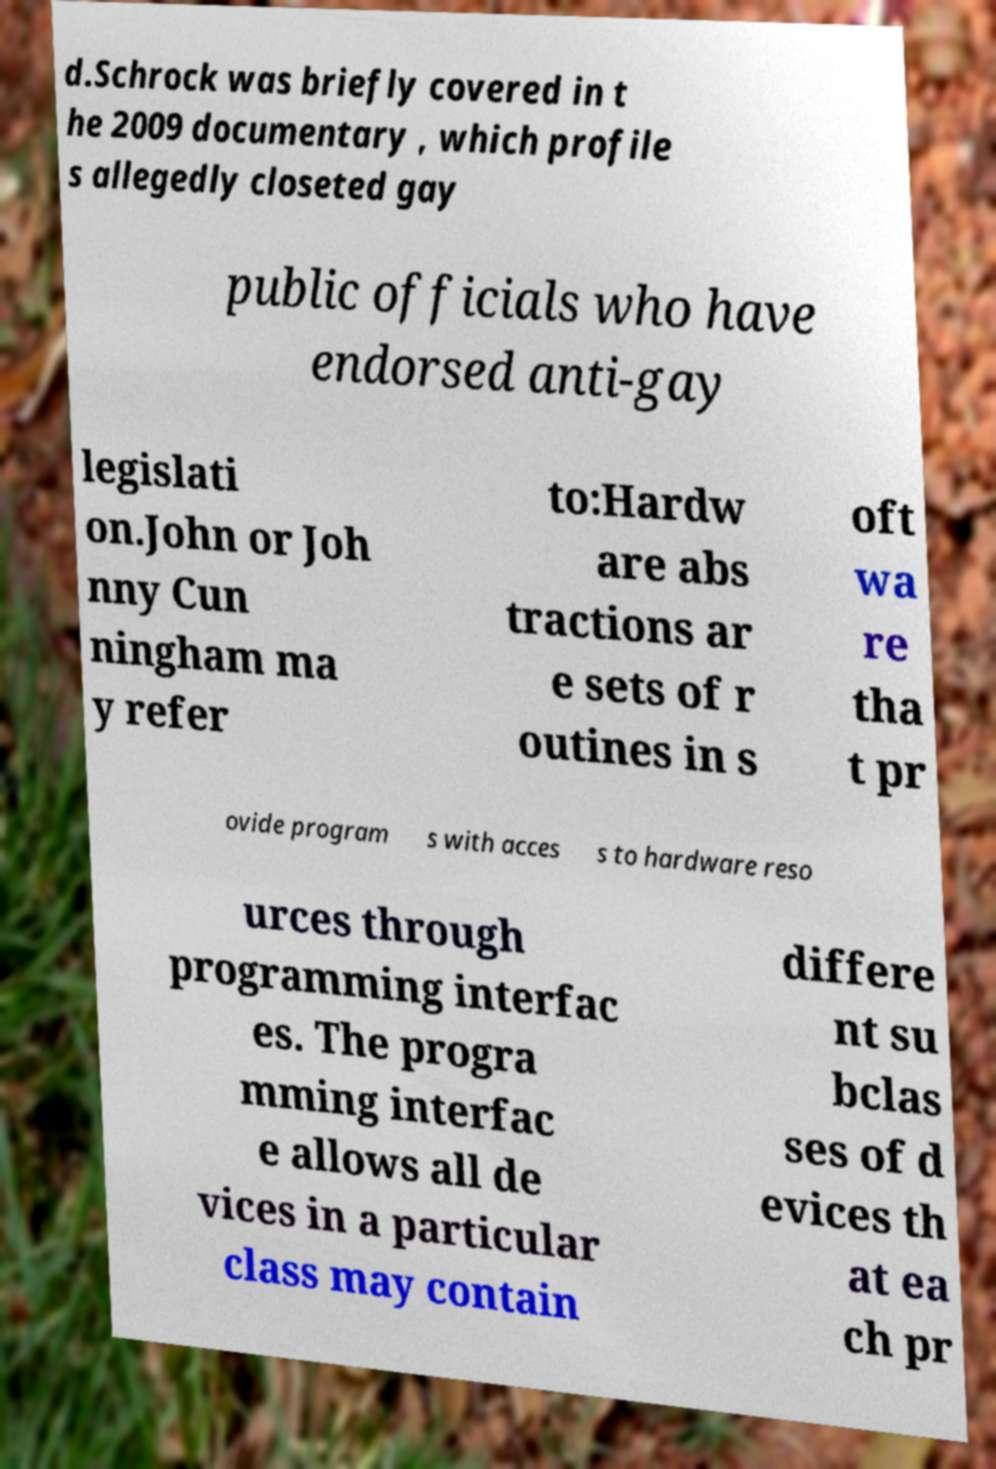I need the written content from this picture converted into text. Can you do that? d.Schrock was briefly covered in t he 2009 documentary , which profile s allegedly closeted gay public officials who have endorsed anti-gay legislati on.John or Joh nny Cun ningham ma y refer to:Hardw are abs tractions ar e sets of r outines in s oft wa re tha t pr ovide program s with acces s to hardware reso urces through programming interfac es. The progra mming interfac e allows all de vices in a particular class may contain differe nt su bclas ses of d evices th at ea ch pr 